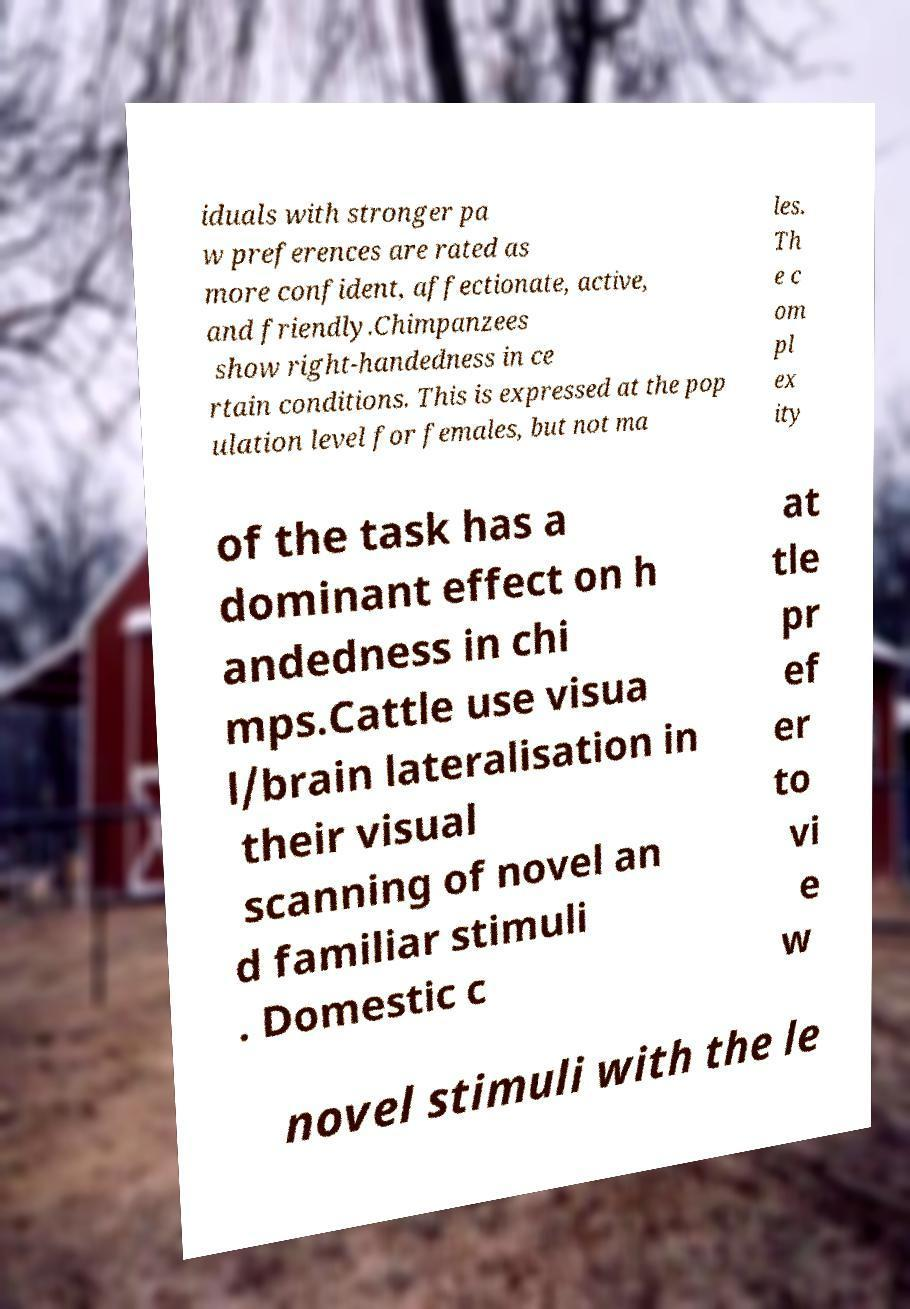Can you read and provide the text displayed in the image?This photo seems to have some interesting text. Can you extract and type it out for me? iduals with stronger pa w preferences are rated as more confident, affectionate, active, and friendly.Chimpanzees show right-handedness in ce rtain conditions. This is expressed at the pop ulation level for females, but not ma les. Th e c om pl ex ity of the task has a dominant effect on h andedness in chi mps.Cattle use visua l/brain lateralisation in their visual scanning of novel an d familiar stimuli . Domestic c at tle pr ef er to vi e w novel stimuli with the le 